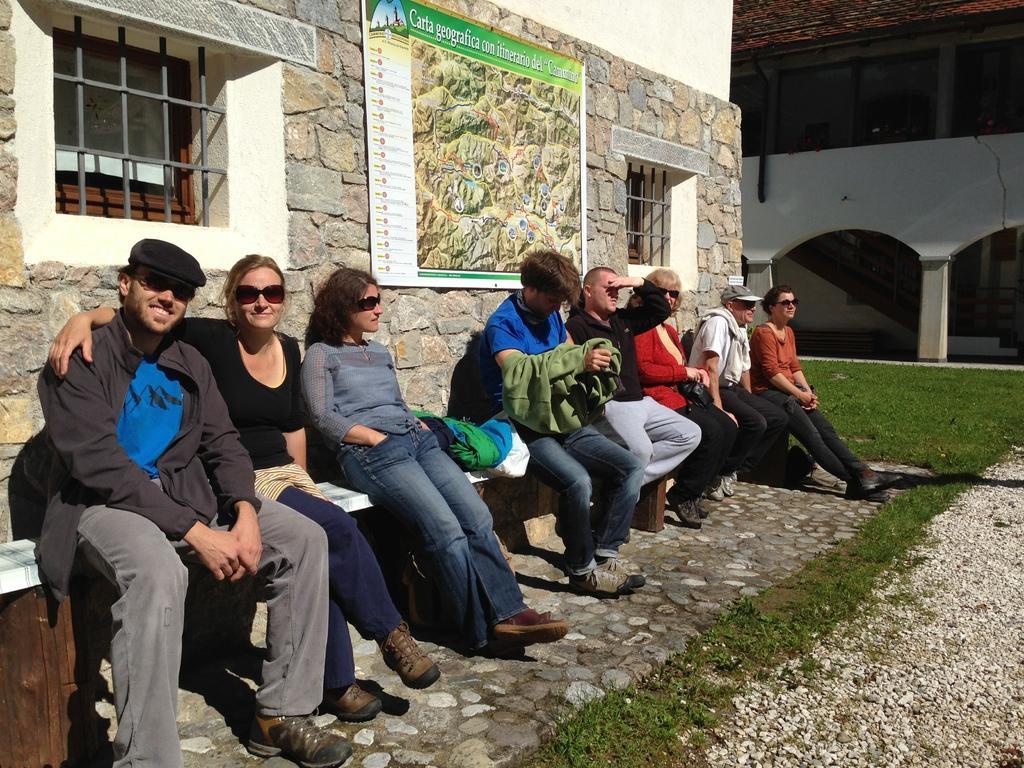Describe this image in one or two sentences. In this image there are few people sitting on a bench that is laid to a wall, in the background there is a house. 